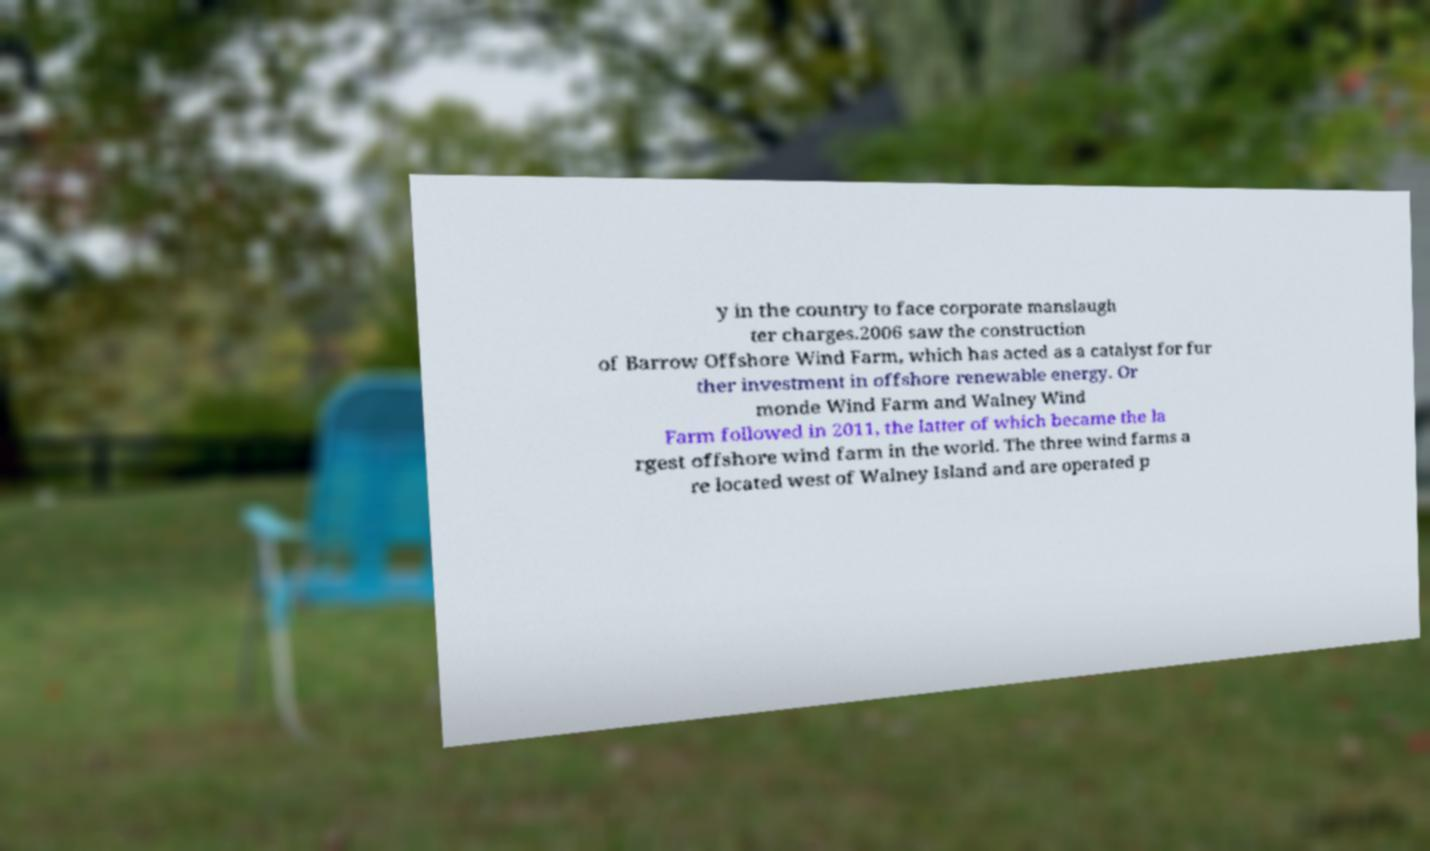I need the written content from this picture converted into text. Can you do that? y in the country to face corporate manslaugh ter charges.2006 saw the construction of Barrow Offshore Wind Farm, which has acted as a catalyst for fur ther investment in offshore renewable energy. Or monde Wind Farm and Walney Wind Farm followed in 2011, the latter of which became the la rgest offshore wind farm in the world. The three wind farms a re located west of Walney Island and are operated p 